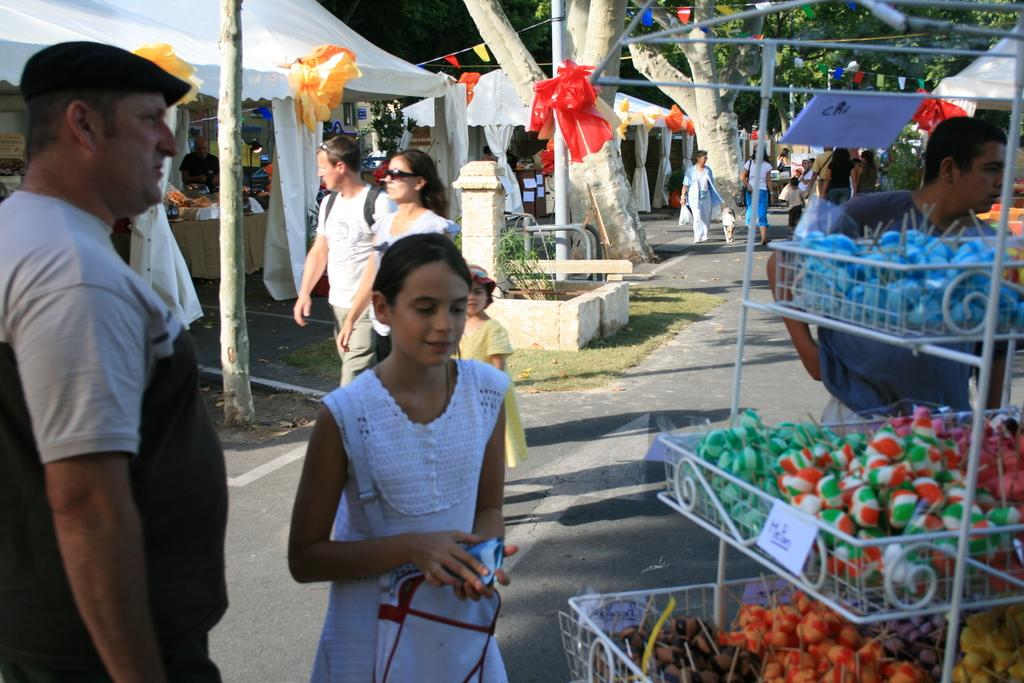What can be seen on the road in the image? There are persons on the road in the image. What type of vegetation is visible in the image? There is grass and trees in the image. How are the lollipops displayed in the image? Lollipops are present in mesh containers in the image. What other items can be seen in the image? There are flags and a board in the image. What type of structure is present in the image? There are stalls in the image. What type of meat is being sold at the stalls in the image? There is no indication of meat being sold in the image; the stalls are not described in detail. How many geese are visible in the image? There are no geese present in the image. 